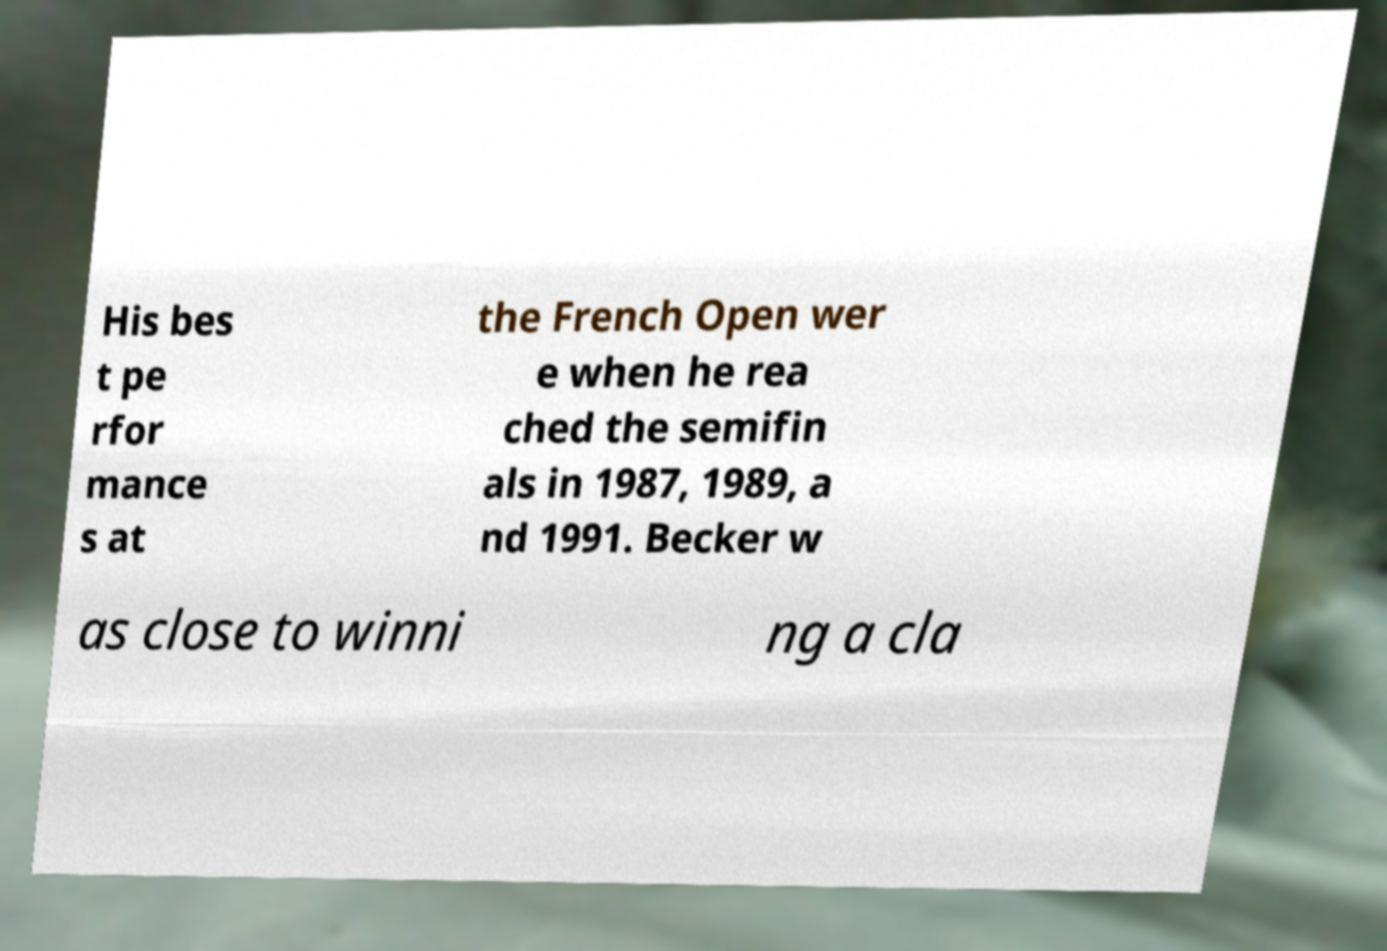For documentation purposes, I need the text within this image transcribed. Could you provide that? His bes t pe rfor mance s at the French Open wer e when he rea ched the semifin als in 1987, 1989, a nd 1991. Becker w as close to winni ng a cla 